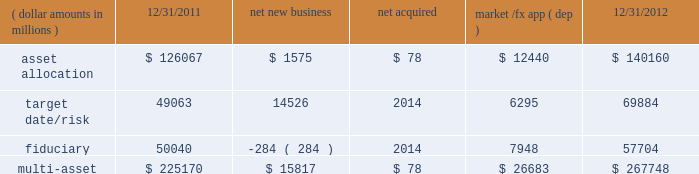Although many clients use both active and passive strategies , the application of these strategies differs greatly .
For example , clients may use index products to gain exposure to a market or asset class pending reallocation to an active manager .
This has the effect of increasing turnover of index aum .
In addition , institutional non-etp index assignments tend to be very large ( multi- billion dollars ) and typically reflect low fee rates .
This has the potential to exaggerate the significance of net flows in institutional index products on blackrock 2019s revenues and earnings .
Equity year-end 2012 equity aum of $ 1.845 trillion increased by $ 285.4 billion , or 18% ( 18 % ) , from the end of 2011 , largely due to flows into regional , country-specific and global mandates and the effect of higher market valuations .
Equity aum growth included $ 54.0 billion in net new business and $ 3.6 billion in new assets related to the acquisition of claymore .
Net new business of $ 54.0 billion was driven by net inflows of $ 53.0 billion and $ 19.1 billion into ishares and non-etp index accounts , respectively .
Passive inflows were offset by active net outflows of $ 18.1 billion , with net outflows of $ 10.0 billion and $ 8.1 billion from fundamental and scientific active equity products , respectively .
Passive strategies represented 84% ( 84 % ) of equity aum with the remaining 16% ( 16 % ) in active mandates .
Institutional investors represented 62% ( 62 % ) of equity aum , while ishares , and retail and hnw represented 29% ( 29 % ) and 9% ( 9 % ) , respectively .
At year-end 2012 , 63% ( 63 % ) of equity aum was managed for clients in the americas ( defined as the united states , caribbean , canada , latin america and iberia ) compared with 28% ( 28 % ) and 9% ( 9 % ) managed for clients in emea and asia-pacific , respectively .
Blackrock 2019s effective fee rates fluctuate due to changes in aum mix .
Approximately half of blackrock 2019s equity aum is tied to international markets , including emerging markets , which tend to have higher fee rates than similar u.s .
Equity strategies .
Accordingly , fluctuations in international equity markets , which do not consistently move in tandem with u.s .
Markets , may have a greater impact on blackrock 2019s effective equity fee rates and revenues .
Fixed income fixed income aum ended 2012 at $ 1.259 trillion , rising $ 11.6 billion , or 1% ( 1 % ) , relative to december 31 , 2011 .
Growth in aum reflected $ 43.3 billion in net new business , excluding the two large previously mentioned low-fee outflows , $ 75.4 billion in market and foreign exchange gains and $ 3.0 billion in new assets related to claymore .
Net new business was led by flows into domestic specialty and global bond mandates , with net inflows of $ 28.8 billion , $ 13.6 billion and $ 3.1 billion into ishares , non-etp index and model-based products , respectively , partially offset by net outflows of $ 2.2 billion from fundamental strategies .
Fixed income aum was split between passive and active strategies with 48% ( 48 % ) and 52% ( 52 % ) , respectively .
Institutional investors represented 74% ( 74 % ) of fixed income aum while ishares and retail and hnw represented 15% ( 15 % ) and 11% ( 11 % ) , respectively .
At year-end 2012 , 59% ( 59 % ) of fixed income aum was managed for clients in the americas compared with 33% ( 33 % ) and 8% ( 8 % ) managed for clients in emea and asia- pacific , respectively .
Multi-asset class component changes in multi-asset class aum ( dollar amounts in millions ) 12/31/2011 net new business acquired market /fx app ( dep ) 12/31/2012 .
Multi-asset class aum totaled $ 267.7 billion at year-end 2012 , up 19% ( 19 % ) , or $ 42.6 billion , reflecting $ 15.8 billion in net new business and $ 26.7 billion in portfolio valuation gains .
Blackrock 2019s multi-asset class team manages a variety of bespoke mandates for a diversified client base that leverages our broad investment expertise in global equities , currencies , bonds and commodities , and our extensive risk management capabilities .
Investment solutions might include a combination of long-only portfolios and alternative investments as well as tactical asset allocation overlays .
At december 31 , 2012 , institutional investors represented 66% ( 66 % ) of multi-asset class aum , while retail and hnw accounted for the remaining aum .
Additionally , 58% ( 58 % ) of multi-asset class aum is managed for clients based in the americas with 37% ( 37 % ) and 5% ( 5 % ) managed for clients in emea and asia-pacific , respectively .
Flows reflected ongoing institutional demand for our advice in an increasingly .
What is the percent change in multi-asset from 12/31/2011 to 12/31/2012? 
Computations: ((267748 - 225170) / 225170)
Answer: 0.18909. 